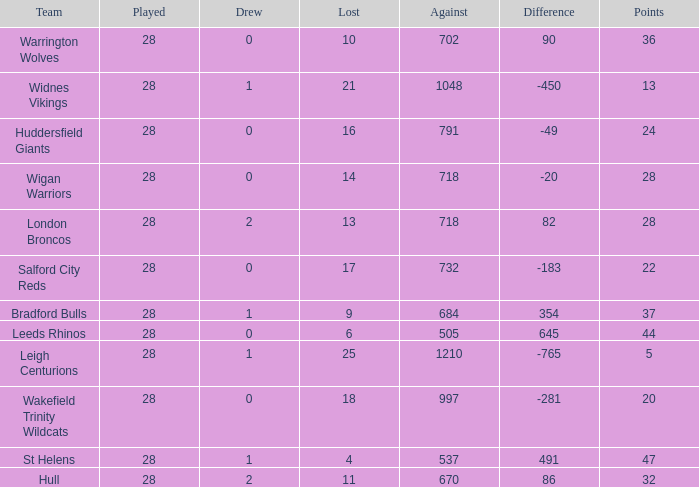What is the average points for a team that lost 4 and played more than 28 games? None. 